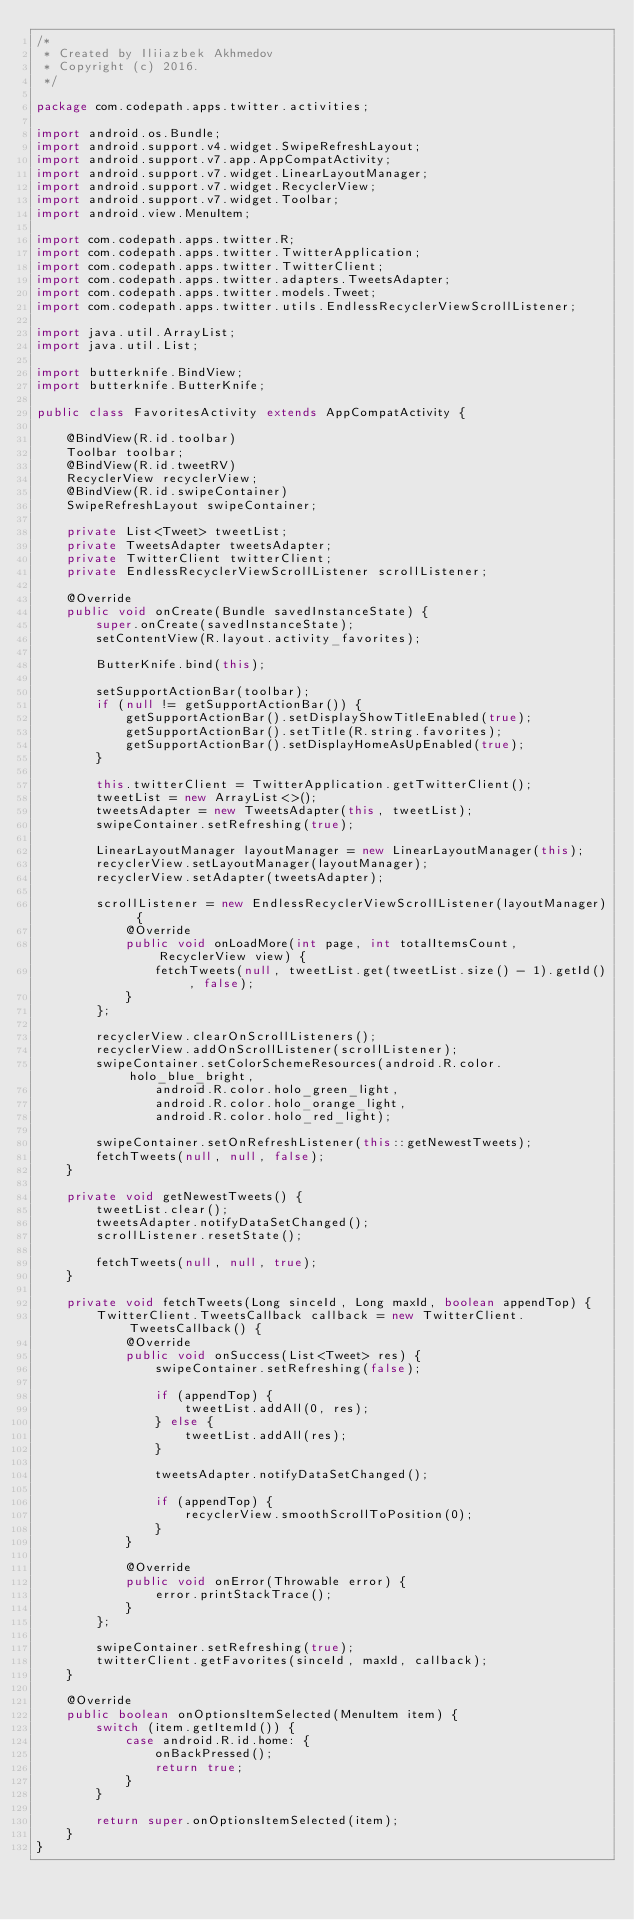<code> <loc_0><loc_0><loc_500><loc_500><_Java_>/*
 * Created by Iliiazbek Akhmedov
 * Copyright (c) 2016.
 */

package com.codepath.apps.twitter.activities;

import android.os.Bundle;
import android.support.v4.widget.SwipeRefreshLayout;
import android.support.v7.app.AppCompatActivity;
import android.support.v7.widget.LinearLayoutManager;
import android.support.v7.widget.RecyclerView;
import android.support.v7.widget.Toolbar;
import android.view.MenuItem;

import com.codepath.apps.twitter.R;
import com.codepath.apps.twitter.TwitterApplication;
import com.codepath.apps.twitter.TwitterClient;
import com.codepath.apps.twitter.adapters.TweetsAdapter;
import com.codepath.apps.twitter.models.Tweet;
import com.codepath.apps.twitter.utils.EndlessRecyclerViewScrollListener;

import java.util.ArrayList;
import java.util.List;

import butterknife.BindView;
import butterknife.ButterKnife;

public class FavoritesActivity extends AppCompatActivity {

    @BindView(R.id.toolbar)
    Toolbar toolbar;
    @BindView(R.id.tweetRV)
    RecyclerView recyclerView;
    @BindView(R.id.swipeContainer)
    SwipeRefreshLayout swipeContainer;

    private List<Tweet> tweetList;
    private TweetsAdapter tweetsAdapter;
    private TwitterClient twitterClient;
    private EndlessRecyclerViewScrollListener scrollListener;

    @Override
    public void onCreate(Bundle savedInstanceState) {
        super.onCreate(savedInstanceState);
        setContentView(R.layout.activity_favorites);

        ButterKnife.bind(this);

        setSupportActionBar(toolbar);
        if (null != getSupportActionBar()) {
            getSupportActionBar().setDisplayShowTitleEnabled(true);
            getSupportActionBar().setTitle(R.string.favorites);
            getSupportActionBar().setDisplayHomeAsUpEnabled(true);
        }

        this.twitterClient = TwitterApplication.getTwitterClient();
        tweetList = new ArrayList<>();
        tweetsAdapter = new TweetsAdapter(this, tweetList);
        swipeContainer.setRefreshing(true);

        LinearLayoutManager layoutManager = new LinearLayoutManager(this);
        recyclerView.setLayoutManager(layoutManager);
        recyclerView.setAdapter(tweetsAdapter);

        scrollListener = new EndlessRecyclerViewScrollListener(layoutManager) {
            @Override
            public void onLoadMore(int page, int totalItemsCount, RecyclerView view) {
                fetchTweets(null, tweetList.get(tweetList.size() - 1).getId(), false);
            }
        };

        recyclerView.clearOnScrollListeners();
        recyclerView.addOnScrollListener(scrollListener);
        swipeContainer.setColorSchemeResources(android.R.color.holo_blue_bright,
                android.R.color.holo_green_light,
                android.R.color.holo_orange_light,
                android.R.color.holo_red_light);

        swipeContainer.setOnRefreshListener(this::getNewestTweets);
        fetchTweets(null, null, false);
    }

    private void getNewestTweets() {
        tweetList.clear();
        tweetsAdapter.notifyDataSetChanged();
        scrollListener.resetState();

        fetchTweets(null, null, true);
    }

    private void fetchTweets(Long sinceId, Long maxId, boolean appendTop) {
        TwitterClient.TweetsCallback callback = new TwitterClient.TweetsCallback() {
            @Override
            public void onSuccess(List<Tweet> res) {
                swipeContainer.setRefreshing(false);

                if (appendTop) {
                    tweetList.addAll(0, res);
                } else {
                    tweetList.addAll(res);
                }

                tweetsAdapter.notifyDataSetChanged();

                if (appendTop) {
                    recyclerView.smoothScrollToPosition(0);
                }
            }

            @Override
            public void onError(Throwable error) {
                error.printStackTrace();
            }
        };

        swipeContainer.setRefreshing(true);
        twitterClient.getFavorites(sinceId, maxId, callback);
    }

    @Override
    public boolean onOptionsItemSelected(MenuItem item) {
        switch (item.getItemId()) {
            case android.R.id.home: {
                onBackPressed();
                return true;
            }
        }

        return super.onOptionsItemSelected(item);
    }
}
</code> 